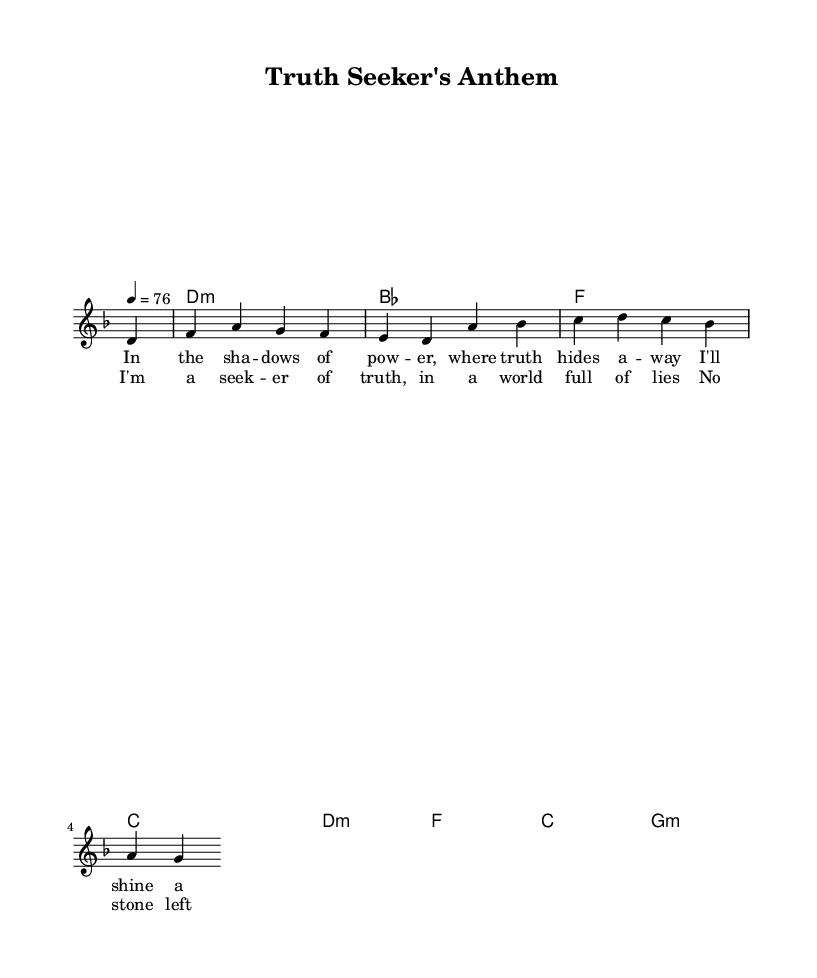What is the key signature of this music? The key signature is D minor, indicated by the presence of one flat (B flat). This is derived from the global settings where it specifies the key is D minor.
Answer: D minor What is the time signature of this music? The time signature is 4/4, often represented in the global settings at the beginning of the music. This indicates that there are four beats in a measure.
Answer: 4/4 What is the tempo marking of this piece? The tempo marking is 76 beats per minute, indicated as "4 = 76" in the global settings. This specifies how fast the piece should be played.
Answer: 76 How many measures are in the melody? The melody consists of 8 measures as determined by the number of distinct sections separated by the vertical lines indicating measure endings.
Answer: 8 What chord follows the D minor chord in the harmonies? The next chord after D minor is B flat, as this can be identified in the chord progression outlined in the harmonies section.
Answer: B flat What is the primary theme expressed in the lyrics? The primary theme expressed in the lyrics is investigating truth and uncovering secrets, depicted by lines that emphasize seeking truth in a world of lies.
Answer: Seeking truth How do the lyrics of the chorus relate to the verses? The chorus captures the essence of perseverance in uncovering the truth, summarizing the message of the verses that talk about shining light on hidden secrets. This relationship reinforces the central theme of truth-seeking throughout the song.
Answer: Perseverance in truth 